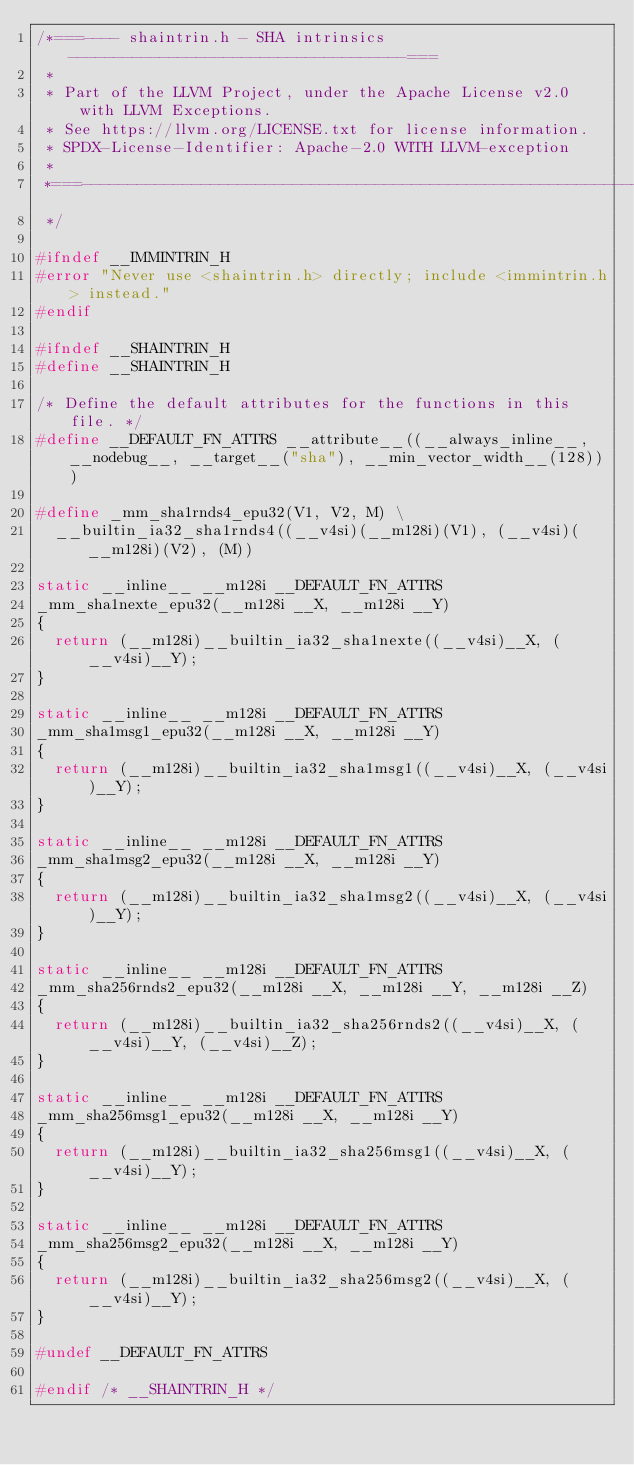<code> <loc_0><loc_0><loc_500><loc_500><_C_>/*===---- shaintrin.h - SHA intrinsics -------------------------------------===
 *
 * Part of the LLVM Project, under the Apache License v2.0 with LLVM Exceptions.
 * See https://llvm.org/LICENSE.txt for license information.
 * SPDX-License-Identifier: Apache-2.0 WITH LLVM-exception
 *
 *===-----------------------------------------------------------------------===
 */

#ifndef __IMMINTRIN_H
#error "Never use <shaintrin.h> directly; include <immintrin.h> instead."
#endif

#ifndef __SHAINTRIN_H
#define __SHAINTRIN_H

/* Define the default attributes for the functions in this file. */
#define __DEFAULT_FN_ATTRS __attribute__((__always_inline__, __nodebug__, __target__("sha"), __min_vector_width__(128)))

#define _mm_sha1rnds4_epu32(V1, V2, M) \
  __builtin_ia32_sha1rnds4((__v4si)(__m128i)(V1), (__v4si)(__m128i)(V2), (M))

static __inline__ __m128i __DEFAULT_FN_ATTRS
_mm_sha1nexte_epu32(__m128i __X, __m128i __Y)
{
  return (__m128i)__builtin_ia32_sha1nexte((__v4si)__X, (__v4si)__Y);
}

static __inline__ __m128i __DEFAULT_FN_ATTRS
_mm_sha1msg1_epu32(__m128i __X, __m128i __Y)
{
  return (__m128i)__builtin_ia32_sha1msg1((__v4si)__X, (__v4si)__Y);
}

static __inline__ __m128i __DEFAULT_FN_ATTRS
_mm_sha1msg2_epu32(__m128i __X, __m128i __Y)
{
  return (__m128i)__builtin_ia32_sha1msg2((__v4si)__X, (__v4si)__Y);
}

static __inline__ __m128i __DEFAULT_FN_ATTRS
_mm_sha256rnds2_epu32(__m128i __X, __m128i __Y, __m128i __Z)
{
  return (__m128i)__builtin_ia32_sha256rnds2((__v4si)__X, (__v4si)__Y, (__v4si)__Z);
}

static __inline__ __m128i __DEFAULT_FN_ATTRS
_mm_sha256msg1_epu32(__m128i __X, __m128i __Y)
{
  return (__m128i)__builtin_ia32_sha256msg1((__v4si)__X, (__v4si)__Y);
}

static __inline__ __m128i __DEFAULT_FN_ATTRS
_mm_sha256msg2_epu32(__m128i __X, __m128i __Y)
{
  return (__m128i)__builtin_ia32_sha256msg2((__v4si)__X, (__v4si)__Y);
}

#undef __DEFAULT_FN_ATTRS

#endif /* __SHAINTRIN_H */
</code> 